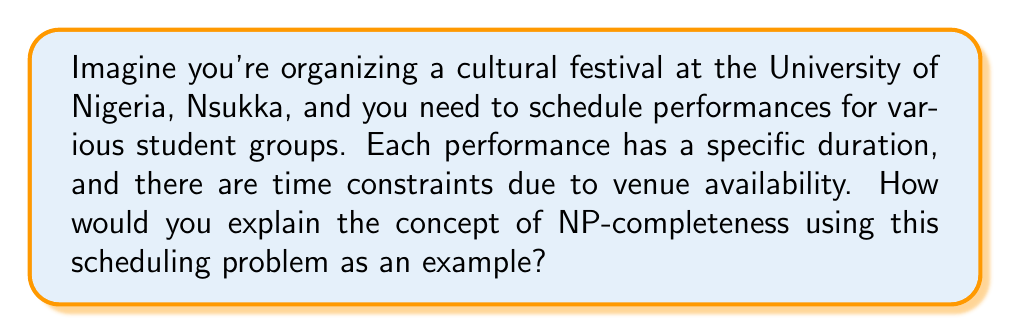Give your solution to this math problem. To understand NP-completeness in the context of this cultural festival scheduling problem, let's break it down step by step:

1. Problem Definition:
   The festival scheduling problem can be formulated as follows:
   - You have $n$ performances, each with a duration $d_i$.
   - The total available time for the festival is $T$.
   - The goal is to determine if all performances can be scheduled within the time limit $T$.

2. NP (Nondeterministic Polynomial time):
   This problem belongs to the NP class because:
   - If someone gives you a proposed schedule, you can quickly verify if it's valid (i.e., all performances fit within time $T$) in polynomial time.
   - However, finding a valid schedule from scratch might be challenging.

3. NP-completeness:
   The festival scheduling problem is actually a variation of the Subset Sum problem, which is known to be NP-complete. Here's why it's NP-complete:

   a) It's in NP (as explained above).
   b) We can reduce a known NP-complete problem (like Subset Sum) to this problem in polynomial time.

4. Reduction from Subset Sum:
   Given a Subset Sum instance with a set of numbers $S = \{s_1, s_2, ..., s_n\}$ and a target sum $k$:
   - Create a scheduling problem where each performance duration $d_i = s_i$.
   - Set the total available time $T = k$.
   - If we can solve the scheduling problem, we've also solved the Subset Sum problem.

5. Implications of NP-completeness:
   - No known polynomial-time algorithm exists to solve this problem optimally for all inputs.
   - As the number of performances increases, the time to find an optimal solution grows exponentially.
   - In practice, we often use approximation algorithms or heuristics for large instances.

6. Real-world relevance:
   For a small cultural festival, you might be able to find an optimal schedule by trying all possibilities. However, for a large-scale event with numerous performances, finding the perfect schedule becomes computationally infeasible. This is why event organizers often use rule-of-thumb approaches or specialized software that may not always produce optimal but usually produce good enough solutions.

The concept of NP-completeness helps us understand why certain problems, like optimal festival scheduling, are inherently difficult and why we often resort to approximate solutions in real-world scenarios.
Answer: The concept of NP-completeness, as illustrated by the festival scheduling problem, implies that:

1. The problem is in NP (solutions can be verified quickly).
2. It's at least as hard as all other problems in NP.
3. No known polynomial-time algorithm exists to solve it optimally.
4. As the problem size increases, the time to find an optimal solution grows exponentially.
5. In practice, approximation algorithms or heuristics are often used for large instances. 